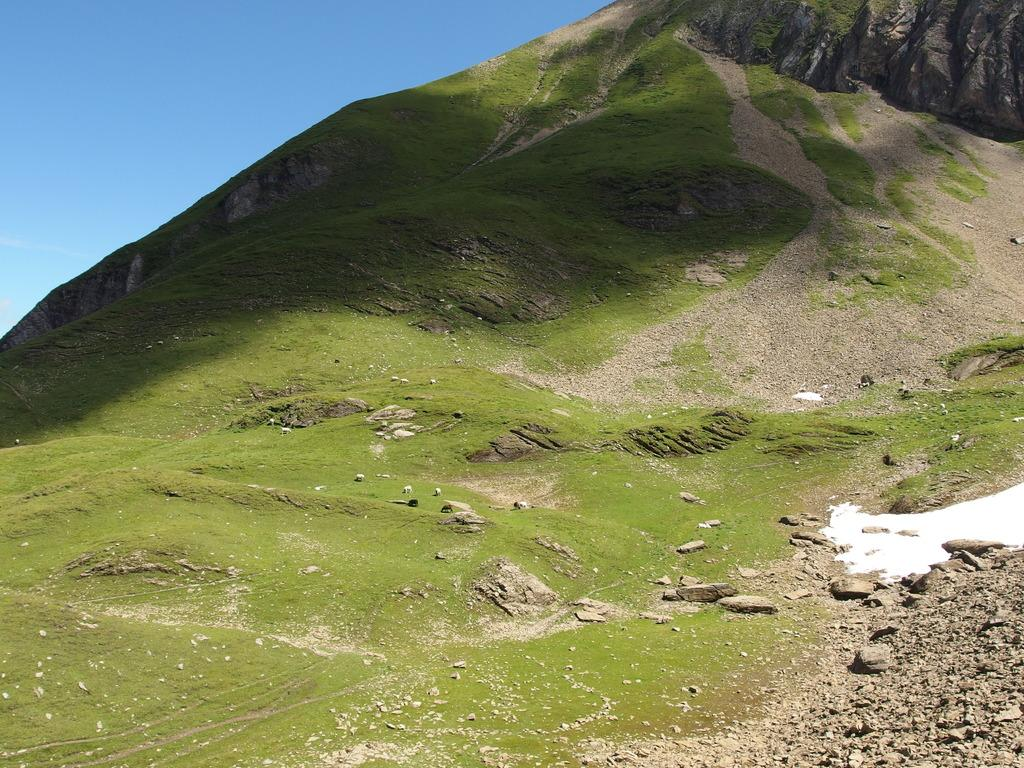What type of natural formation can be seen in the image? There are mountains in the image. What is present on the mountains in the image? There is grass on the mountain and rocks visible in the image. What color is the sky in the background of the image? The sky is blue in the background of the image. Can you tell me how much toothpaste is needed to clean the rocks in the image? There is no toothpaste present in the image, and toothpaste is not used to clean rocks. Is there a tent visible in the image? No, there is no tent present in the image. 